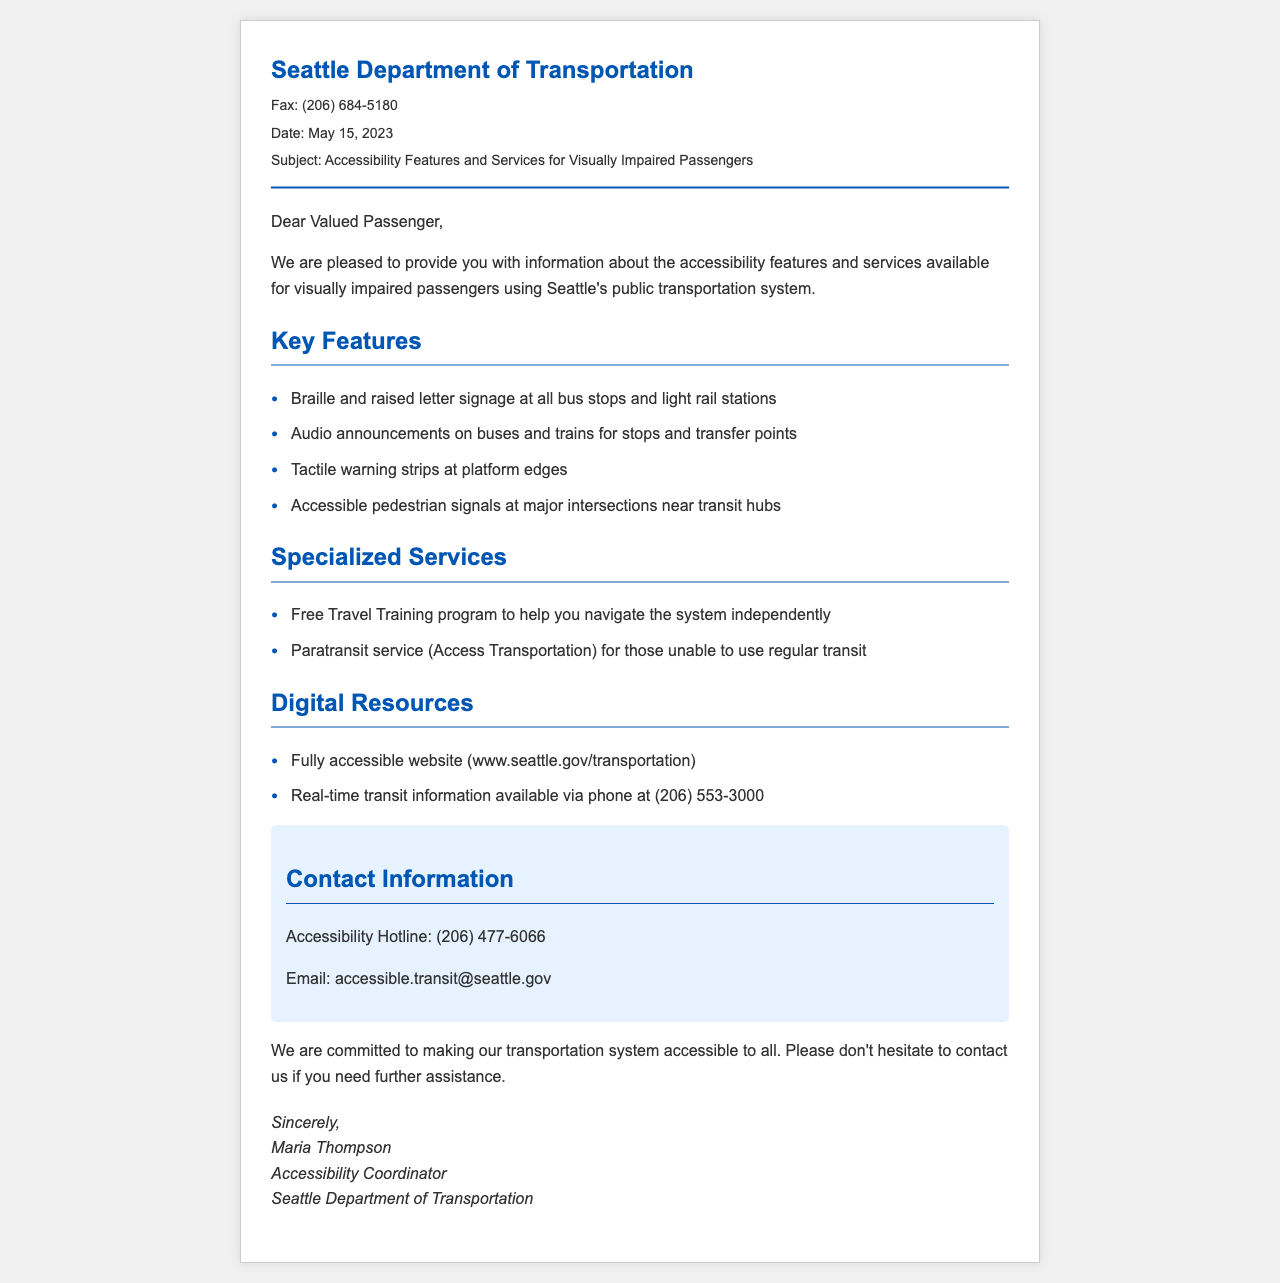What is the fax number for the Seattle Department of Transportation? The fax number can be found in the header section of the document.
Answer: (206) 684-5180 What date was the fax sent? The date is mentioned at the top of the document.
Answer: May 15, 2023 Who is the Accessibility Coordinator? The name of the Accessibility Coordinator is provided at the end of the document.
Answer: Maria Thompson What service helps you navigate the public transportation system? The service is described under the specialized services section.
Answer: Free Travel Training program What is the accessible phone number for real-time transit information? This number is located in the digital resources section of the document.
Answer: (206) 553-3000 What type of signage is provided at bus stops and light rail stations? This information is listed under key features of the accessibility services.
Answer: Braille and raised letter signage How can you contact the Accessibility Hotline? The contact information section provides this detail.
Answer: (206) 477-6066 What are tactile warning strips used for? The context can be inferred from the key features section regarding safety at platform edges.
Answer: Safety at platform edges What specialized service is available for those unable to use regular transit? This service is mentioned under specialized services in the document.
Answer: Paratransit service (Access Transportation) 